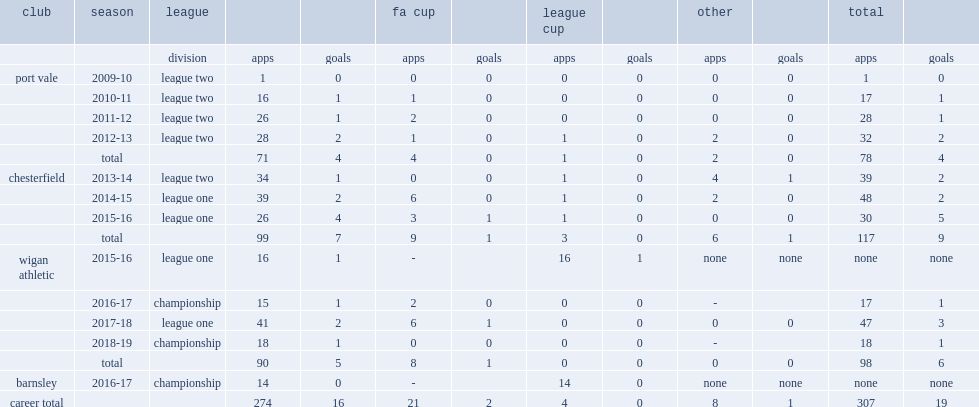Which club did sam morsy play for in 2015-16? Wigan athletic. 